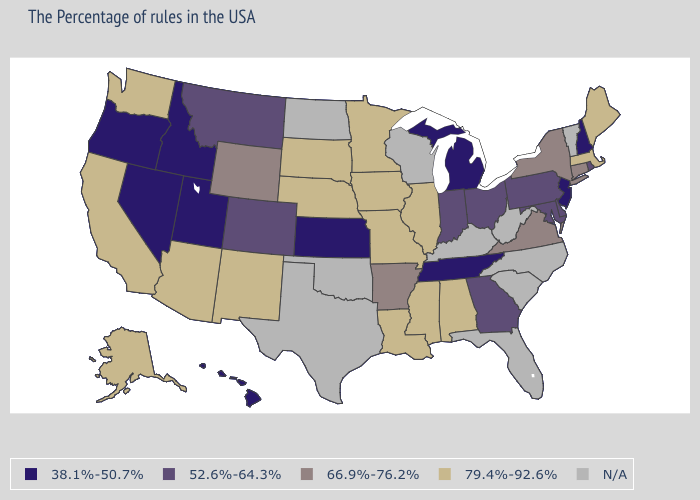Name the states that have a value in the range 52.6%-64.3%?
Write a very short answer. Rhode Island, Delaware, Maryland, Pennsylvania, Ohio, Georgia, Indiana, Colorado, Montana. Name the states that have a value in the range N/A?
Quick response, please. Vermont, North Carolina, South Carolina, West Virginia, Florida, Kentucky, Wisconsin, Oklahoma, Texas, North Dakota. Among the states that border Oregon , which have the highest value?
Concise answer only. California, Washington. What is the value of Rhode Island?
Answer briefly. 52.6%-64.3%. Name the states that have a value in the range N/A?
Concise answer only. Vermont, North Carolina, South Carolina, West Virginia, Florida, Kentucky, Wisconsin, Oklahoma, Texas, North Dakota. Name the states that have a value in the range 66.9%-76.2%?
Short answer required. Connecticut, New York, Virginia, Arkansas, Wyoming. What is the value of Washington?
Write a very short answer. 79.4%-92.6%. Name the states that have a value in the range 79.4%-92.6%?
Write a very short answer. Maine, Massachusetts, Alabama, Illinois, Mississippi, Louisiana, Missouri, Minnesota, Iowa, Nebraska, South Dakota, New Mexico, Arizona, California, Washington, Alaska. Name the states that have a value in the range N/A?
Be succinct. Vermont, North Carolina, South Carolina, West Virginia, Florida, Kentucky, Wisconsin, Oklahoma, Texas, North Dakota. What is the highest value in states that border Oregon?
Give a very brief answer. 79.4%-92.6%. What is the lowest value in states that border Michigan?
Answer briefly. 52.6%-64.3%. Does Mississippi have the highest value in the South?
Quick response, please. Yes. Name the states that have a value in the range 79.4%-92.6%?
Short answer required. Maine, Massachusetts, Alabama, Illinois, Mississippi, Louisiana, Missouri, Minnesota, Iowa, Nebraska, South Dakota, New Mexico, Arizona, California, Washington, Alaska. Name the states that have a value in the range 79.4%-92.6%?
Give a very brief answer. Maine, Massachusetts, Alabama, Illinois, Mississippi, Louisiana, Missouri, Minnesota, Iowa, Nebraska, South Dakota, New Mexico, Arizona, California, Washington, Alaska. Among the states that border New Mexico , which have the highest value?
Concise answer only. Arizona. 